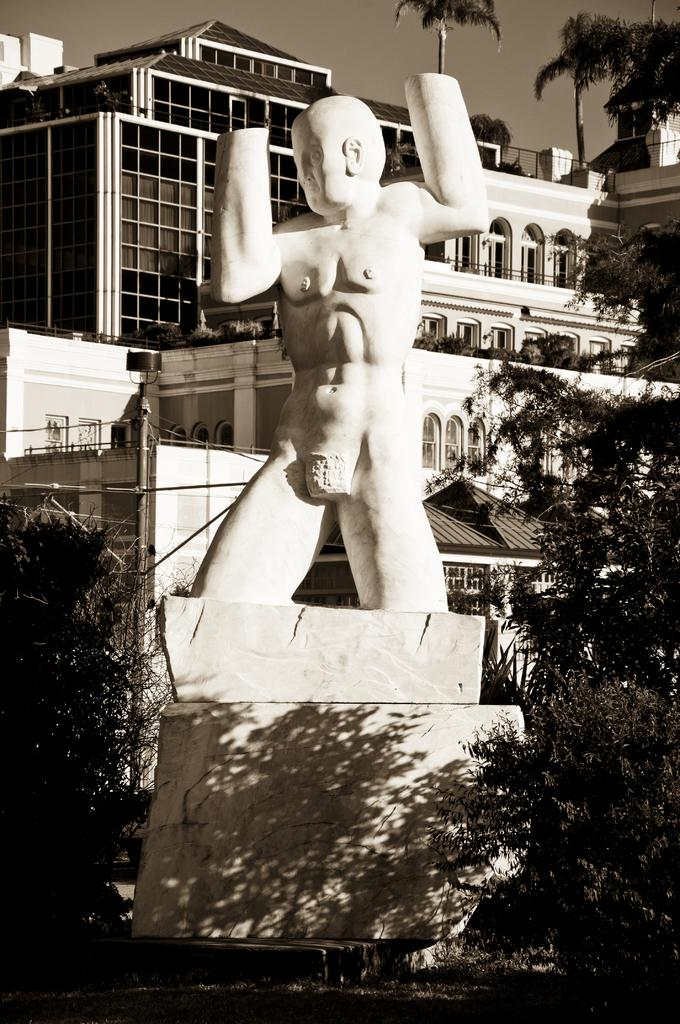What is the main subject of the image? There is a sculpture in the image. What other elements can be seen in the image? There are trees, a building, and the sky visible in the image. What is the color scheme of the image? The image is black and white. Can you tell me how many yaks are grazing near the sculpture in the image? There are no yaks present in the image; it features a sculpture, trees, a building, and the sky. What date is marked on the calendar in the image? There is no calendar present in the image. 